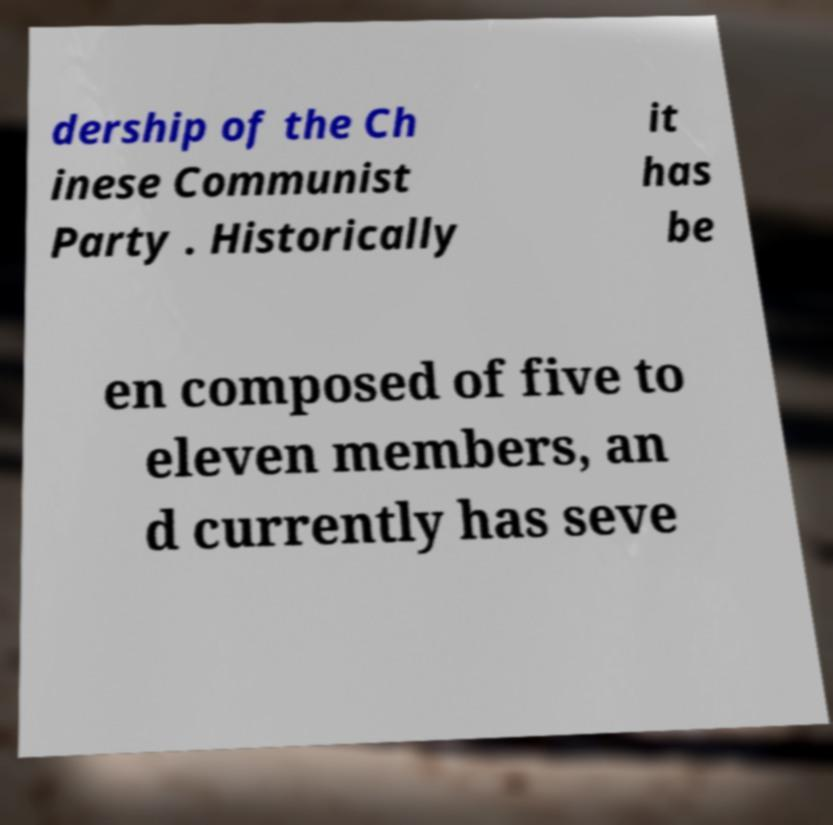Please read and relay the text visible in this image. What does it say? dership of the Ch inese Communist Party . Historically it has be en composed of five to eleven members, an d currently has seve 